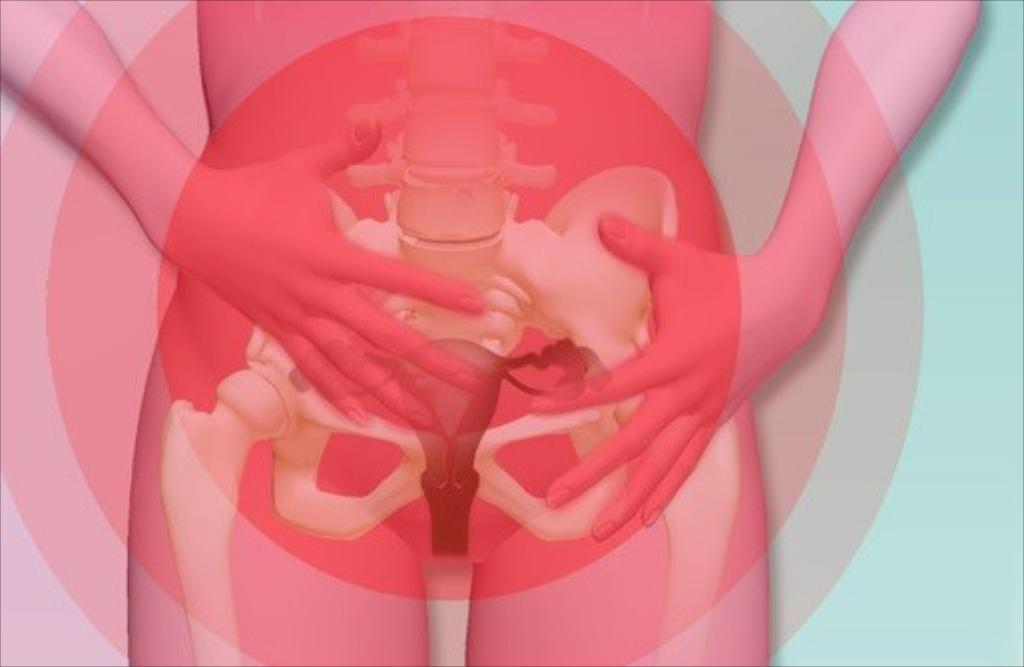What type of image is being depicted? The image is an animated picture. What is the main subject of the image? The image shows an inner view of a human body. What type of cable can be seen running through the human body in the image? There is no cable present in the image; it shows an inner view of a human body without any external objects. How many lizards can be seen crawling inside the human body in the image? There are no lizards present in the image; it shows an inner view of a human body without any living organisms. Where can an icicle be seen in the image? There is no icicle present in the image; it shows an inner view of a human body without any ice formations. 